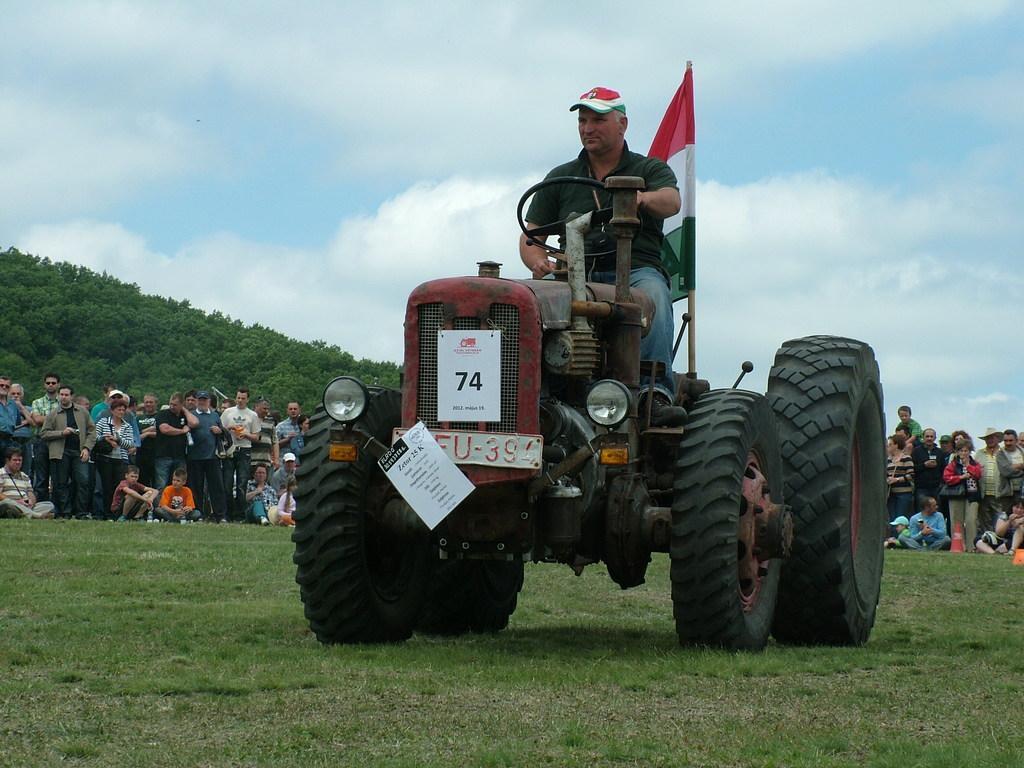Could you give a brief overview of what you see in this image? In the given image i can see a person driving a vehicle,flag,grass,trees and people. 